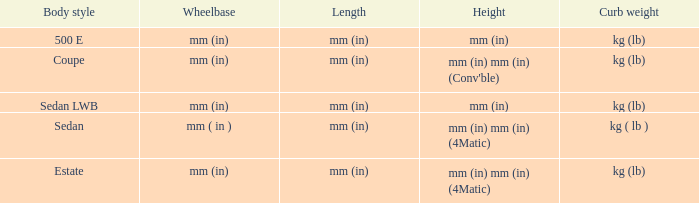What's the length of the model with Sedan body style? Mm (in). 